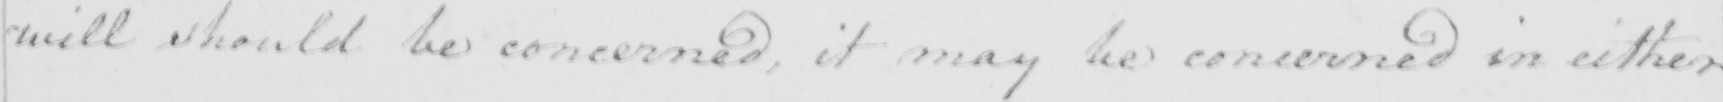Transcribe the text shown in this historical manuscript line. will should be concerned , it may be concerned in either 